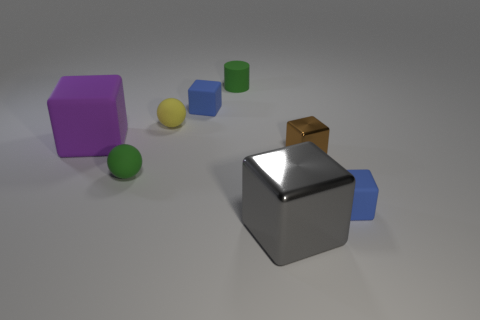Subtract all purple blocks. How many blocks are left? 4 Add 1 brown rubber things. How many objects exist? 9 Subtract all gray cubes. How many cubes are left? 4 Subtract all brown cylinders. How many blue blocks are left? 2 Subtract 1 cubes. How many cubes are left? 4 Subtract all blue balls. Subtract all purple cylinders. How many balls are left? 2 Subtract all balls. How many objects are left? 6 Subtract all purple rubber things. Subtract all green matte objects. How many objects are left? 5 Add 6 green rubber cylinders. How many green rubber cylinders are left? 7 Add 2 big shiny things. How many big shiny things exist? 3 